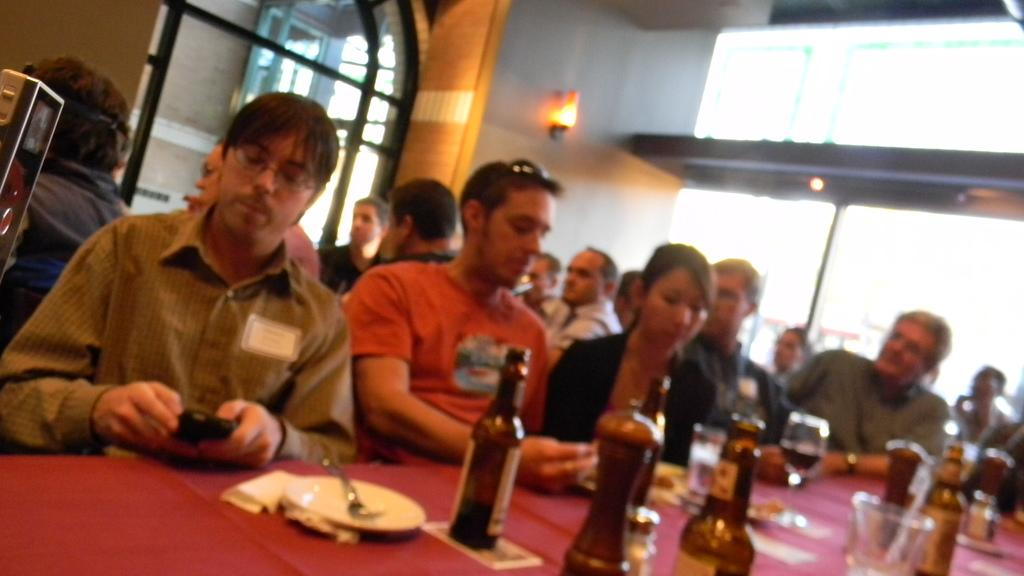What are the persons in the image doing? The persons in the image are sitting on chairs. What is in front of the chairs? There is a table in front of the chairs. What items can be seen on the table? There are bottles, glasses, and plates on the table. What is above the table? There are lights on top of the table. Is there any source of natural light in the room? Yes, there is a window in the room. What type of butter is being used to grease the floor in the image? There is no butter or indication of floor greasing in the image. What type of motion is being performed by the persons in the image? The persons in the image are sitting, which is a stationary position, so there is no motion being performed. 